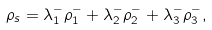<formula> <loc_0><loc_0><loc_500><loc_500>\rho _ { s } = \lambda _ { 1 } ^ { - } \rho _ { 1 } ^ { - } + \lambda _ { 2 } ^ { - } \rho _ { 2 } ^ { - } + \lambda _ { 3 } ^ { - } \rho _ { 3 } ^ { - } ,</formula> 